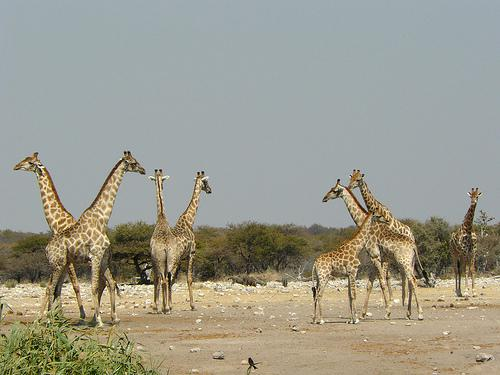Question: what are those animals?
Choices:
A. Giraffes.
B. Zebras.
C. Cows.
D. Horses.
Answer with the letter. Answer: A Question: where are they?
Choices:
A. In the USA.
B. In the park.
C. In africa.
D. At the zoo.
Answer with the letter. Answer: C Question: what color are they?
Choices:
A. Blue and black.
B. Red and yellow.
C. Silver and gold.
D. Brown and white.
Answer with the letter. Answer: D Question: what is in the background?
Choices:
A. Trees.
B. Cars.
C. The ocean.
D. Boats.
Answer with the letter. Answer: A Question: how many giraffes?
Choices:
A. 8.
B. 12.
C. 13.
D. 5.
Answer with the letter. Answer: A 